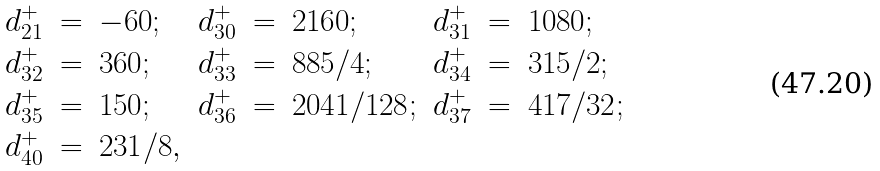Convert formula to latex. <formula><loc_0><loc_0><loc_500><loc_500>\begin{array} { r c l r c l r c l } d _ { 2 1 } ^ { + } & = & - 6 0 ; & d _ { 3 0 } ^ { + } & = & 2 1 6 0 ; & d _ { 3 1 } ^ { + } & = & 1 0 8 0 ; \\ d _ { 3 2 } ^ { + } & = & 3 6 0 ; & d _ { 3 3 } ^ { + } & = & 8 8 5 / 4 ; & d _ { 3 4 } ^ { + } & = & { 3 1 5 } / 2 ; \\ d _ { 3 5 } ^ { + } & = & 1 5 0 ; & d _ { 3 6 } ^ { + } & = & { 2 0 4 1 } / { 1 2 8 } ; & d _ { 3 7 } ^ { + } & = & { 4 1 7 } / { 3 2 } ; \\ d _ { 4 0 } ^ { + } & = & { 2 3 1 } / 8 , & & & & & & \end{array}</formula> 